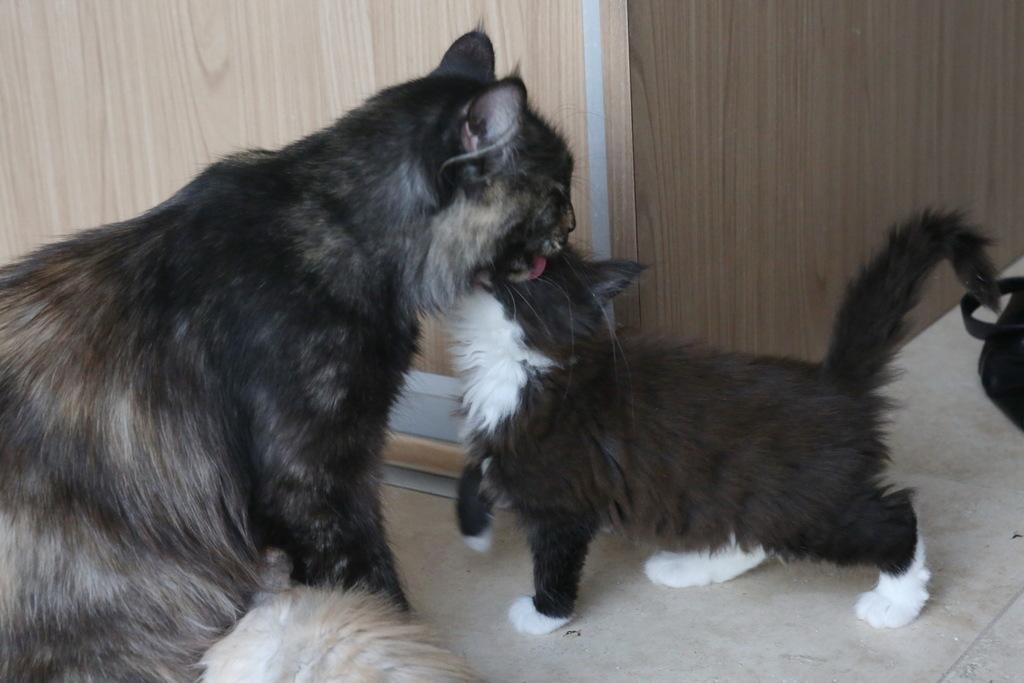Please provide a concise description of this image. In this image I can see there are two cats visible in front of the wooden wall. 